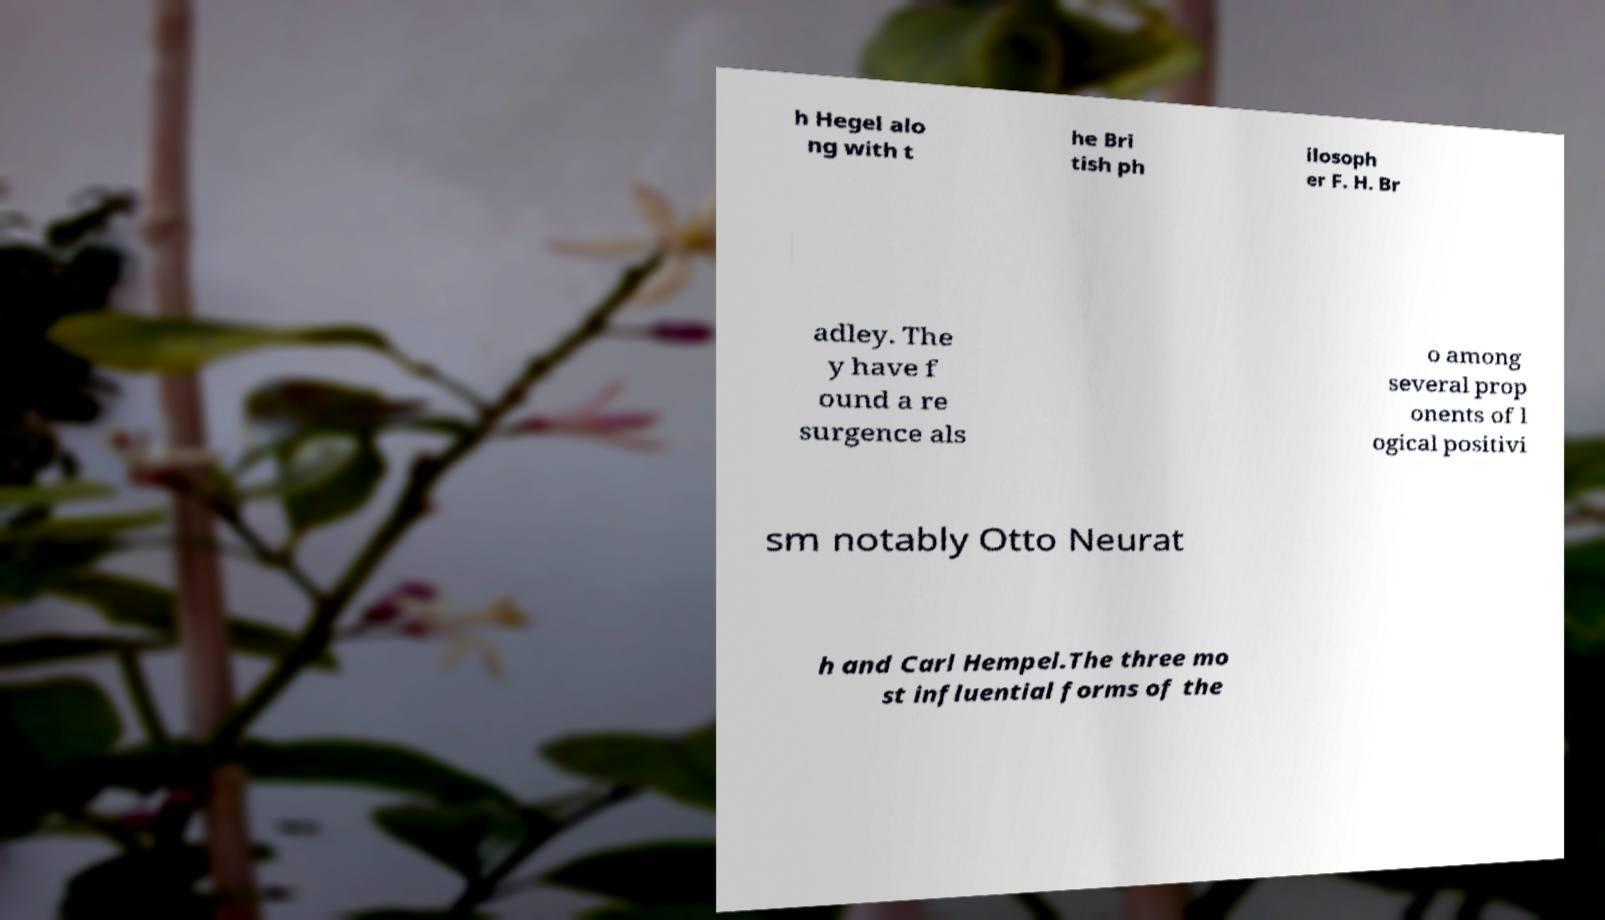Could you extract and type out the text from this image? h Hegel alo ng with t he Bri tish ph ilosoph er F. H. Br adley. The y have f ound a re surgence als o among several prop onents of l ogical positivi sm notably Otto Neurat h and Carl Hempel.The three mo st influential forms of the 